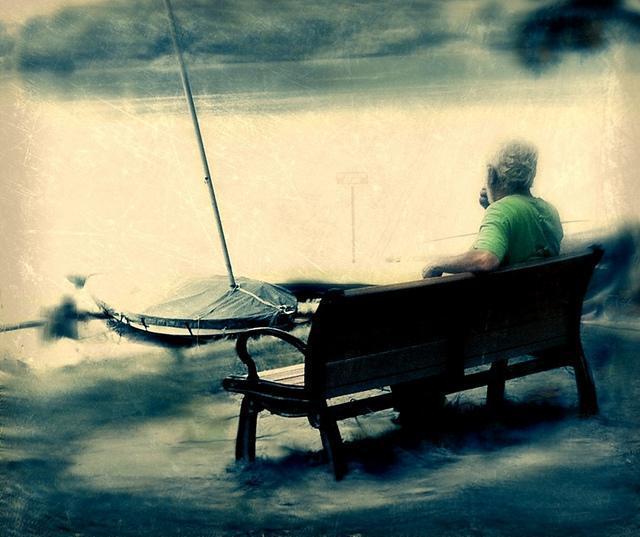How many train cars can be seen?
Give a very brief answer. 0. 